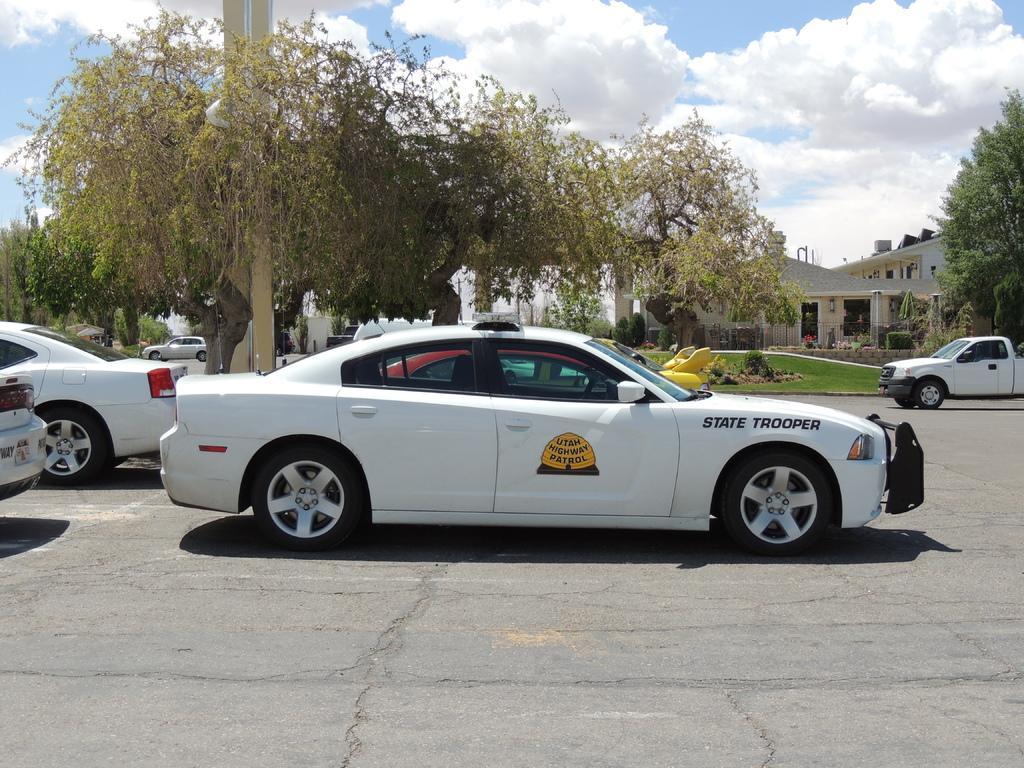Describe this image in one or two sentences. In this image I can see few vehicles, trees, houses and poles. The sky is in blue and white color. 